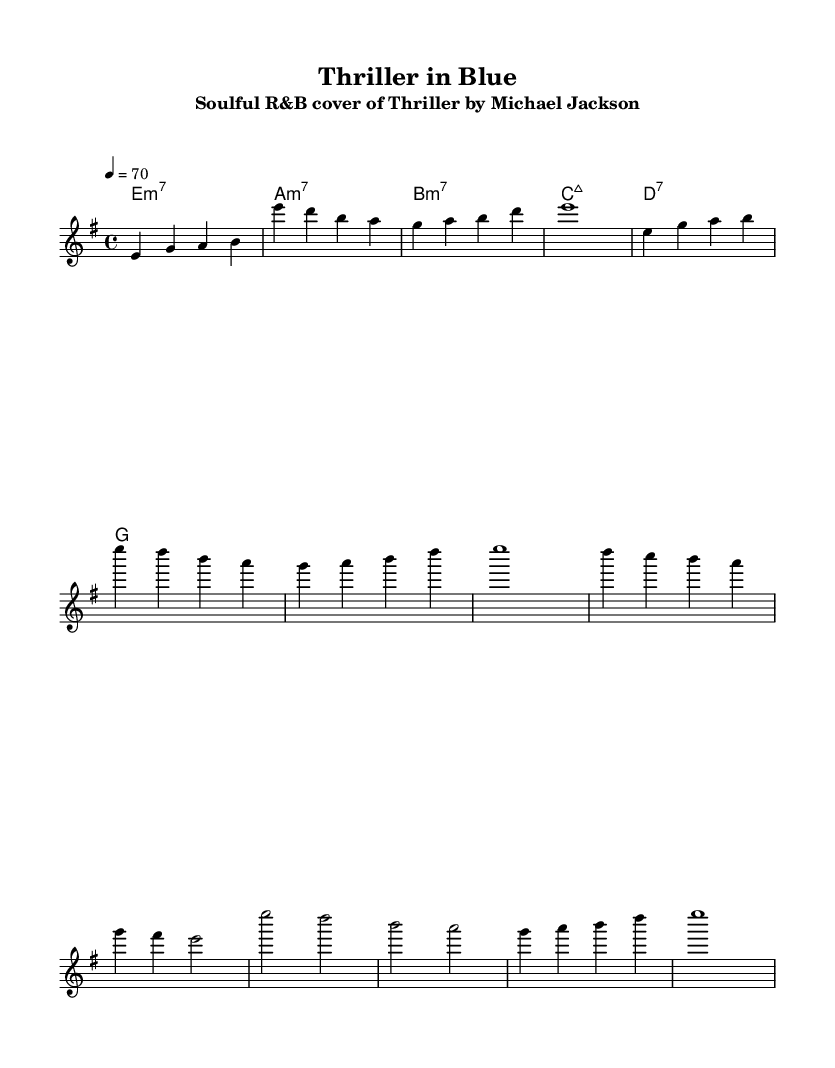What is the key signature of this music? The key signature is indicated at the beginning of the sheet music. In the music, "e minor" is specified, which relates to the number of sharps or flats. E minor has one sharp, F#.
Answer: E minor What is the time signature of the piece? The time signature is located near the start of the sheet music. It is written as "4/4," which means there are four beats in each measure and a quarter note receives one beat.
Answer: 4/4 What is the tempo marking in the score? The tempo is indicated at the beginning of the piece with the marking "4 = 70." This means that the piece should be played at a tempo of 70 beats per minute with each quarter note being one beat.
Answer: 70 What is the first chord in the harmony section? The first chord is written in the chord progression under the melody. It is "e:min7," which is an E minor seventh chord.
Answer: E:min7 How many measures are there in the intro section? The intro section contains a series of notes grouped visually in the sheet music. Counting the measures given, there are four measures in the intro.
Answer: 4 What musical genre is this piece classified under? The title of the piece indicates its classification: "Thriller in Blue," which suggests it is a soulful R&B cover of Michael Jackson's "Thriller." Given its style and presentation, it fits within the Rhythm and Blues genre.
Answer: Rhythm and Blues What is the last chord notated in the harmony section? The last chord in the given harmony section can be found by looking at the final notation listed under the chord names. It is "g," which is a G major chord.
Answer: g 